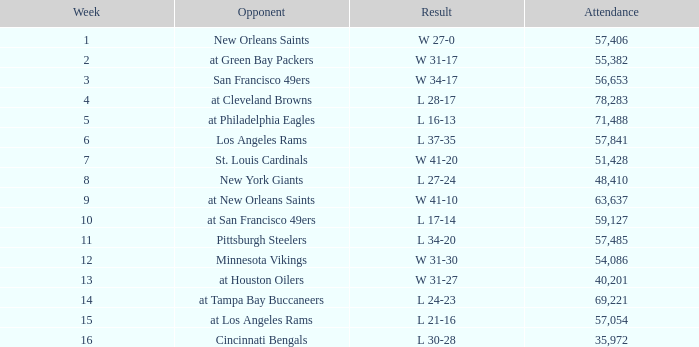What was the specific date the team faced the new orleans saints? September 6, 1981. 